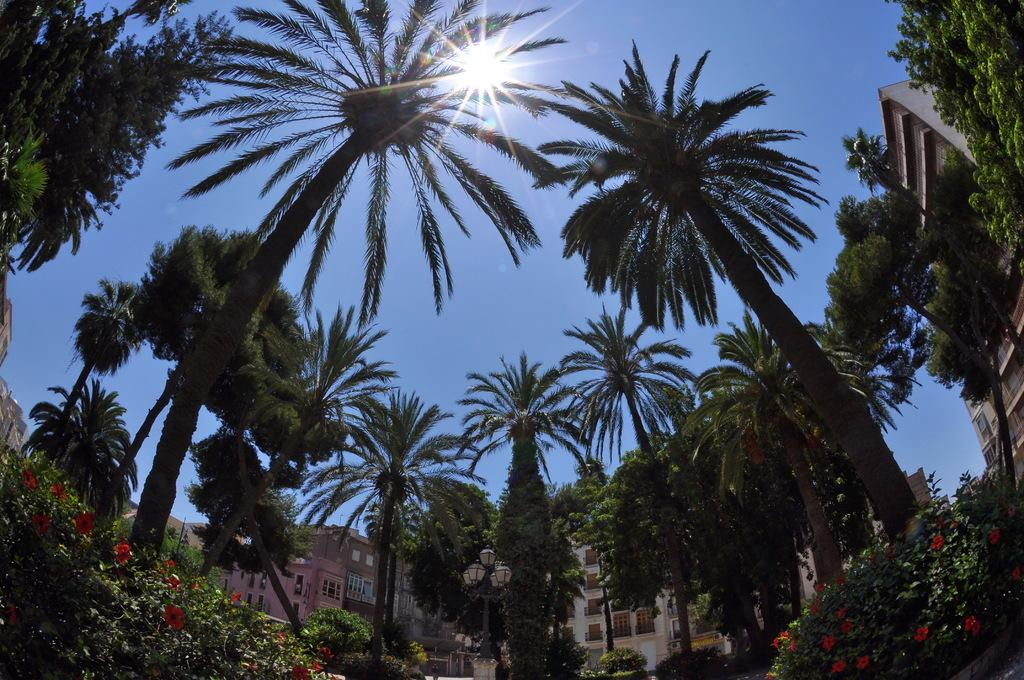What type of vegetation can be seen in the image? There are trees and flowers in the image. What structures are visible in the background of the image? There are buildings in the background of the image. What is visible in the sky in the image? The sky is visible in the image, and the sun is observable at the top of the image. What type of market is being held in the image? There is no market present in the image; it features trees, flowers, buildings, and the sky with the sun. What committee is responsible for organizing the trees and flowers in the image? There is no committee responsible for organizing the trees and flowers in the image; they are naturally occurring elements in the environment. 